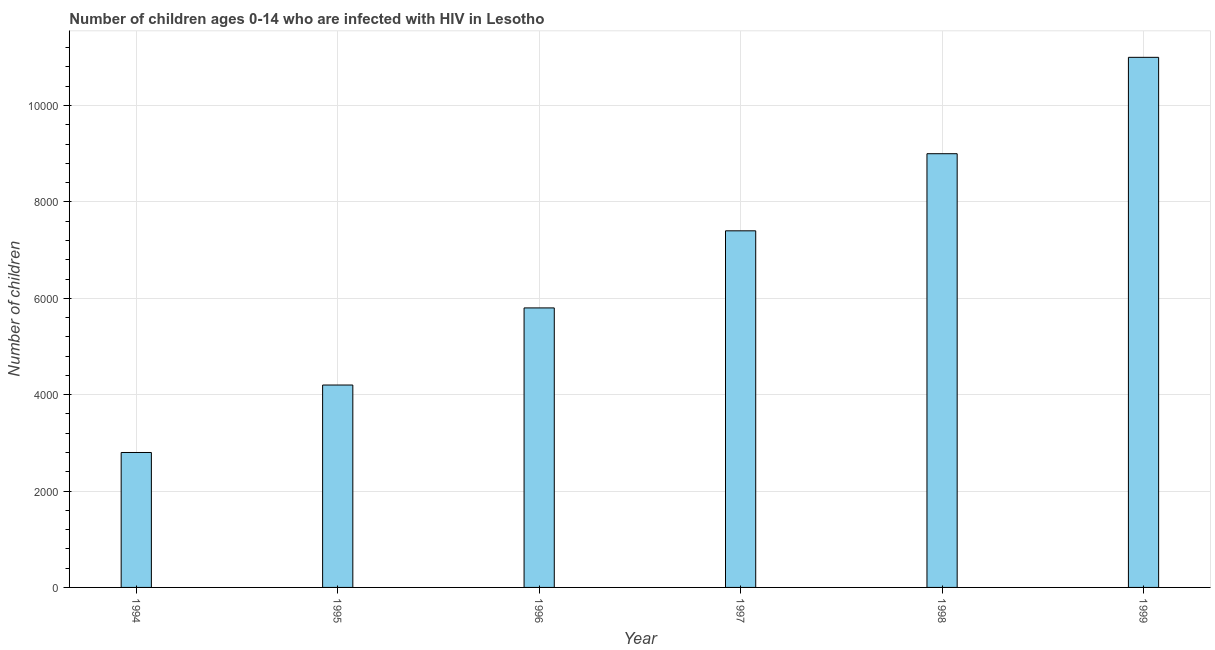Does the graph contain grids?
Provide a short and direct response. Yes. What is the title of the graph?
Keep it short and to the point. Number of children ages 0-14 who are infected with HIV in Lesotho. What is the label or title of the Y-axis?
Give a very brief answer. Number of children. What is the number of children living with hiv in 1994?
Your response must be concise. 2800. Across all years, what is the maximum number of children living with hiv?
Provide a short and direct response. 1.10e+04. Across all years, what is the minimum number of children living with hiv?
Your answer should be very brief. 2800. In which year was the number of children living with hiv maximum?
Your answer should be very brief. 1999. What is the sum of the number of children living with hiv?
Ensure brevity in your answer.  4.02e+04. What is the difference between the number of children living with hiv in 1994 and 1997?
Provide a short and direct response. -4600. What is the average number of children living with hiv per year?
Your answer should be compact. 6700. What is the median number of children living with hiv?
Provide a succinct answer. 6600. Do a majority of the years between 1998 and 1994 (inclusive) have number of children living with hiv greater than 2000 ?
Your answer should be very brief. Yes. What is the ratio of the number of children living with hiv in 1998 to that in 1999?
Provide a short and direct response. 0.82. Is the number of children living with hiv in 1996 less than that in 1998?
Keep it short and to the point. Yes. What is the difference between the highest and the second highest number of children living with hiv?
Your answer should be compact. 2000. What is the difference between the highest and the lowest number of children living with hiv?
Offer a very short reply. 8200. What is the difference between two consecutive major ticks on the Y-axis?
Give a very brief answer. 2000. Are the values on the major ticks of Y-axis written in scientific E-notation?
Give a very brief answer. No. What is the Number of children in 1994?
Keep it short and to the point. 2800. What is the Number of children of 1995?
Your response must be concise. 4200. What is the Number of children in 1996?
Offer a very short reply. 5800. What is the Number of children in 1997?
Your response must be concise. 7400. What is the Number of children of 1998?
Your response must be concise. 9000. What is the Number of children in 1999?
Your answer should be very brief. 1.10e+04. What is the difference between the Number of children in 1994 and 1995?
Your response must be concise. -1400. What is the difference between the Number of children in 1994 and 1996?
Ensure brevity in your answer.  -3000. What is the difference between the Number of children in 1994 and 1997?
Make the answer very short. -4600. What is the difference between the Number of children in 1994 and 1998?
Provide a short and direct response. -6200. What is the difference between the Number of children in 1994 and 1999?
Give a very brief answer. -8200. What is the difference between the Number of children in 1995 and 1996?
Keep it short and to the point. -1600. What is the difference between the Number of children in 1995 and 1997?
Ensure brevity in your answer.  -3200. What is the difference between the Number of children in 1995 and 1998?
Offer a terse response. -4800. What is the difference between the Number of children in 1995 and 1999?
Give a very brief answer. -6800. What is the difference between the Number of children in 1996 and 1997?
Offer a very short reply. -1600. What is the difference between the Number of children in 1996 and 1998?
Make the answer very short. -3200. What is the difference between the Number of children in 1996 and 1999?
Give a very brief answer. -5200. What is the difference between the Number of children in 1997 and 1998?
Your response must be concise. -1600. What is the difference between the Number of children in 1997 and 1999?
Provide a short and direct response. -3600. What is the difference between the Number of children in 1998 and 1999?
Your answer should be compact. -2000. What is the ratio of the Number of children in 1994 to that in 1995?
Your answer should be compact. 0.67. What is the ratio of the Number of children in 1994 to that in 1996?
Keep it short and to the point. 0.48. What is the ratio of the Number of children in 1994 to that in 1997?
Keep it short and to the point. 0.38. What is the ratio of the Number of children in 1994 to that in 1998?
Give a very brief answer. 0.31. What is the ratio of the Number of children in 1994 to that in 1999?
Keep it short and to the point. 0.26. What is the ratio of the Number of children in 1995 to that in 1996?
Offer a very short reply. 0.72. What is the ratio of the Number of children in 1995 to that in 1997?
Your answer should be compact. 0.57. What is the ratio of the Number of children in 1995 to that in 1998?
Your response must be concise. 0.47. What is the ratio of the Number of children in 1995 to that in 1999?
Your answer should be compact. 0.38. What is the ratio of the Number of children in 1996 to that in 1997?
Keep it short and to the point. 0.78. What is the ratio of the Number of children in 1996 to that in 1998?
Make the answer very short. 0.64. What is the ratio of the Number of children in 1996 to that in 1999?
Your answer should be compact. 0.53. What is the ratio of the Number of children in 1997 to that in 1998?
Give a very brief answer. 0.82. What is the ratio of the Number of children in 1997 to that in 1999?
Your answer should be very brief. 0.67. What is the ratio of the Number of children in 1998 to that in 1999?
Keep it short and to the point. 0.82. 